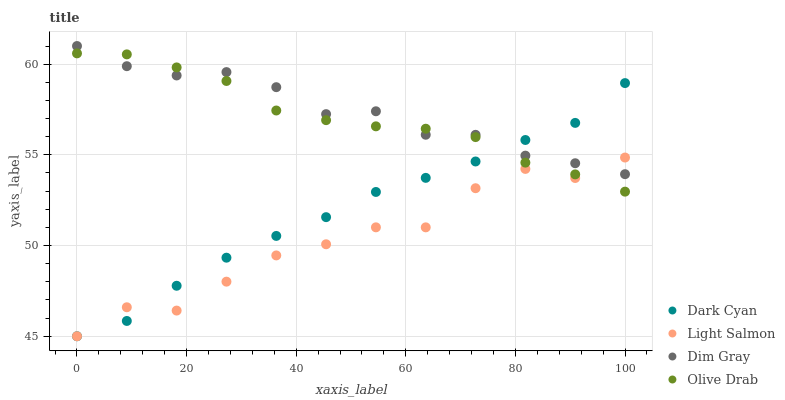Does Light Salmon have the minimum area under the curve?
Answer yes or no. Yes. Does Dim Gray have the maximum area under the curve?
Answer yes or no. Yes. Does Dim Gray have the minimum area under the curve?
Answer yes or no. No. Does Light Salmon have the maximum area under the curve?
Answer yes or no. No. Is Dark Cyan the smoothest?
Answer yes or no. Yes. Is Light Salmon the roughest?
Answer yes or no. Yes. Is Dim Gray the smoothest?
Answer yes or no. No. Is Dim Gray the roughest?
Answer yes or no. No. Does Dark Cyan have the lowest value?
Answer yes or no. Yes. Does Dim Gray have the lowest value?
Answer yes or no. No. Does Dim Gray have the highest value?
Answer yes or no. Yes. Does Light Salmon have the highest value?
Answer yes or no. No. Does Olive Drab intersect Light Salmon?
Answer yes or no. Yes. Is Olive Drab less than Light Salmon?
Answer yes or no. No. Is Olive Drab greater than Light Salmon?
Answer yes or no. No. 